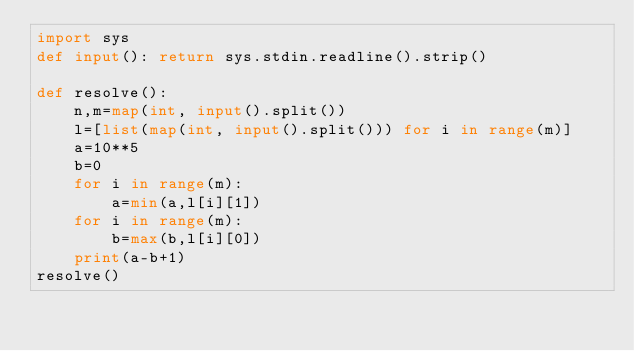Convert code to text. <code><loc_0><loc_0><loc_500><loc_500><_Python_>import sys
def input(): return sys.stdin.readline().strip()

def resolve():
    n,m=map(int, input().split())
    l=[list(map(int, input().split())) for i in range(m)]
    a=10**5
    b=0
    for i in range(m):
        a=min(a,l[i][1])
    for i in range(m):
        b=max(b,l[i][0])
    print(a-b+1)
resolve()</code> 